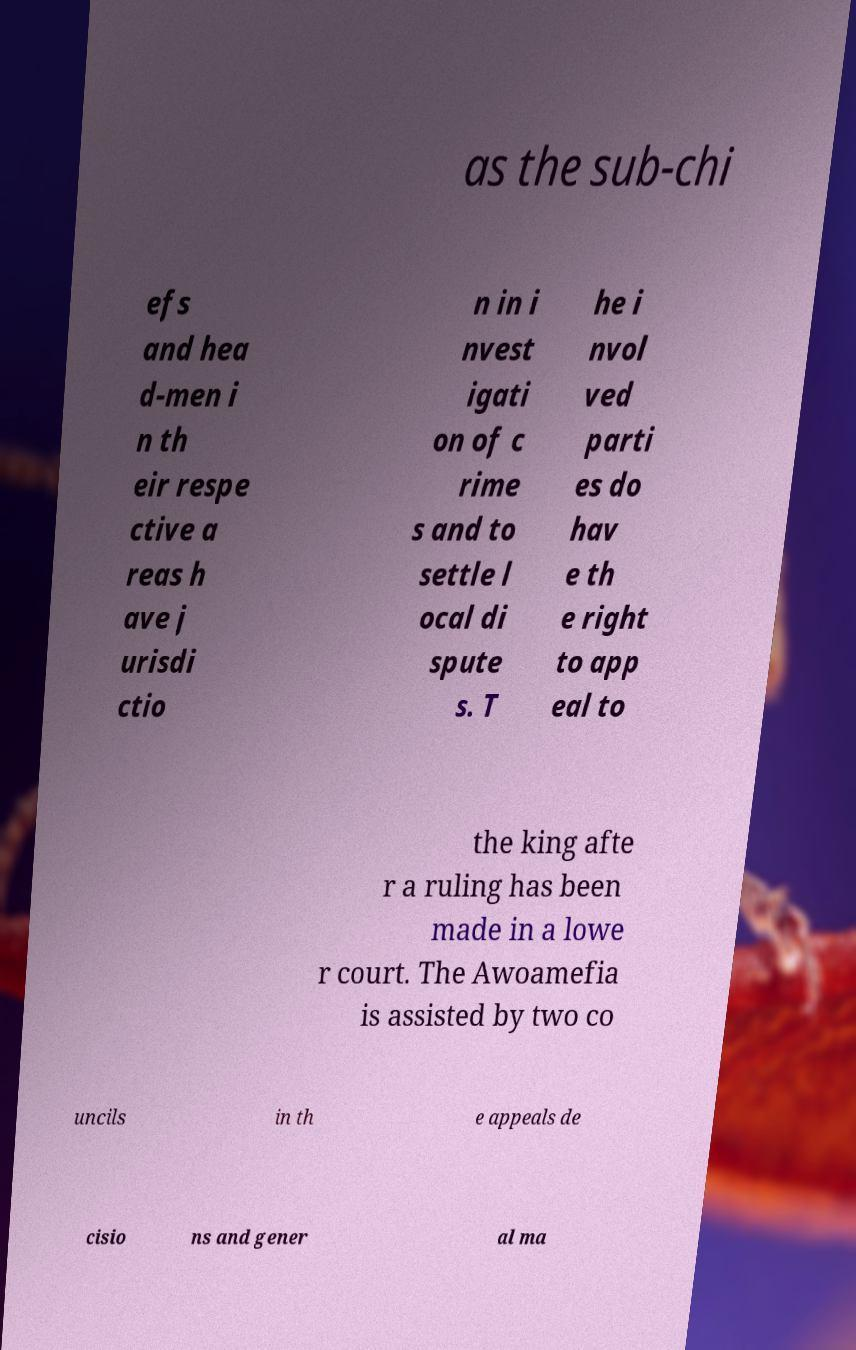Could you assist in decoding the text presented in this image and type it out clearly? as the sub-chi efs and hea d-men i n th eir respe ctive a reas h ave j urisdi ctio n in i nvest igati on of c rime s and to settle l ocal di spute s. T he i nvol ved parti es do hav e th e right to app eal to the king afte r a ruling has been made in a lowe r court. The Awoamefia is assisted by two co uncils in th e appeals de cisio ns and gener al ma 